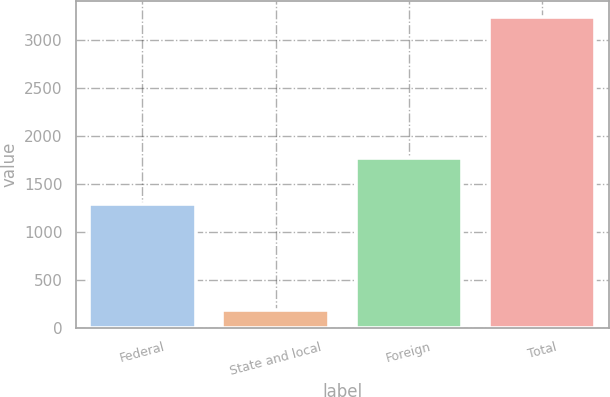Convert chart to OTSL. <chart><loc_0><loc_0><loc_500><loc_500><bar_chart><fcel>Federal<fcel>State and local<fcel>Foreign<fcel>Total<nl><fcel>1290<fcel>184<fcel>1774<fcel>3248<nl></chart> 